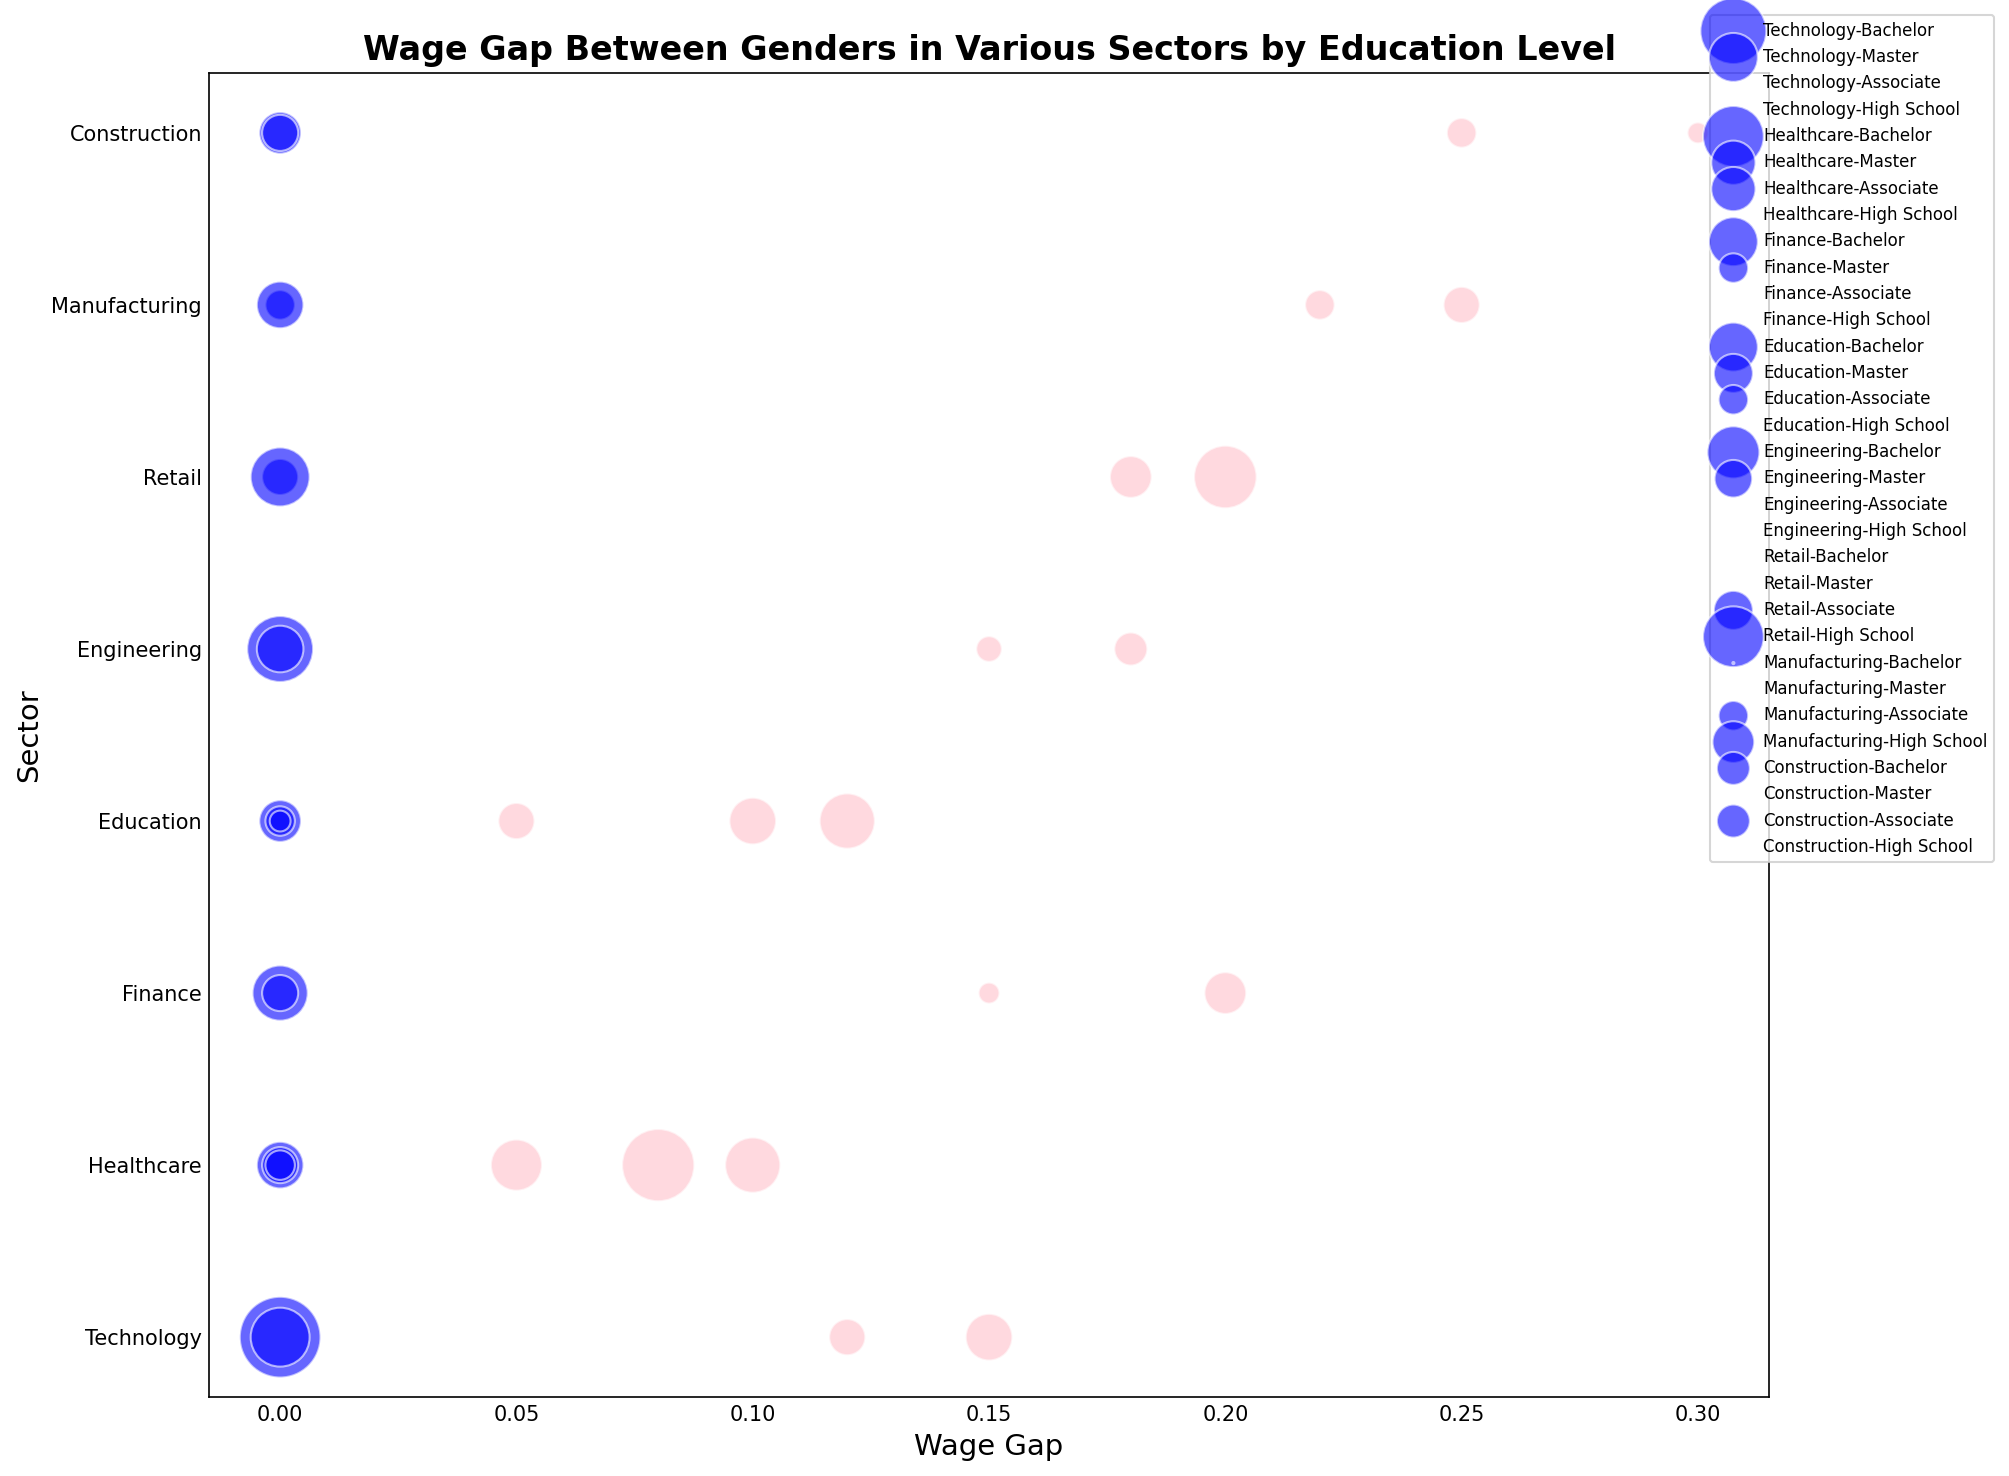Which sector has the highest wage gap for Bachelor's degree holders? The wage gaps for Bachelor's degree holders in different sectors are depicted by the horizontal position of the pink bubbles along the Wage Gap axis. By observing, Construction has the highest wage gap for Bachelor's degree holders.
Answer: Construction How does the wage gap compare between male and female Master’s degree holders in Technology? In the figure, males have no wage gap (0) whereas females have a wage gap of 0.12. So the wage gap is higher for females with a Master’s degree in Technology.
Answer: Female gap > Male gap What is the difference in the number of employees between male and female Associate degree holders in Healthcare? The bubble size represents the number of employees. Male employees have a smaller bubble with 200,000 while female employees have a larger bubble with 700,000. The difference is 700,000 - 200,000 = 500,000.
Answer: 500,000 In which sector do female Bachelor's degree holders face the highest wage gap compared to other sectors? To find this, one needs to look for the pink bubbles in the Bachelor’s category and compare their horizontal positions. Construction has the pink bubble furthest to the right, indicating the highest wage gap.
Answer: Construction Which sector has the smallest wage gap for female employees with a Master’s degree? By observing the bubbles for females with a Master’s degree in each sector, we see that Healthcare has the bubble closest to the left, indicating the smallest wage gap of 0.05.
Answer: Healthcare Compare the wage gap for female employees with a high school education in Retail and Manufacturing. Which sector has a higher gap? The bubbles representing female employees with a high school education in Retail and Manufacturing show different horizontal positions. Retail bubbles are placed at 0.20 wage gap while Manufacturing is at 0.25 wage gap. So, Manufacturing has a higher wage gap.
Answer: Manufacturing What is the average wage gap for female employees in the Finance sector? Female employees in Finance have wage gaps of 0.20 with a Bachelor’s and 0.15 with a Master’s degree. The average wage gap is (0.20 + 0.15) / 2 = 0.175.
Answer: 0.175 In the Retail sector, which gender has a larger number of employees with a high school education? The size of the bubbles indicates that females have a larger number of employees than males for high school education in Retail as the pink bubble is larger than the blue bubble.
Answer: Female Which sector shows the smallest size bubble for female employees with an Associate degree? By observing the bubble sizes for female employees with an Associate degree across sectors, Manufacturing shows the smallest bubble, indicating the smallest number of employees.
Answer: Manufacturing What is the total number of female employees with a Bachelor’s degree across all sectors? Summing up the number of employees for females with a Bachelor’s degree in all sectors: Technology (500,000), Healthcare (1,200,000), Finance (400,000), Education (700,000), Engineering (250,000), Construction (100,000) gives 3,150,000.
Answer: 3,150,000 